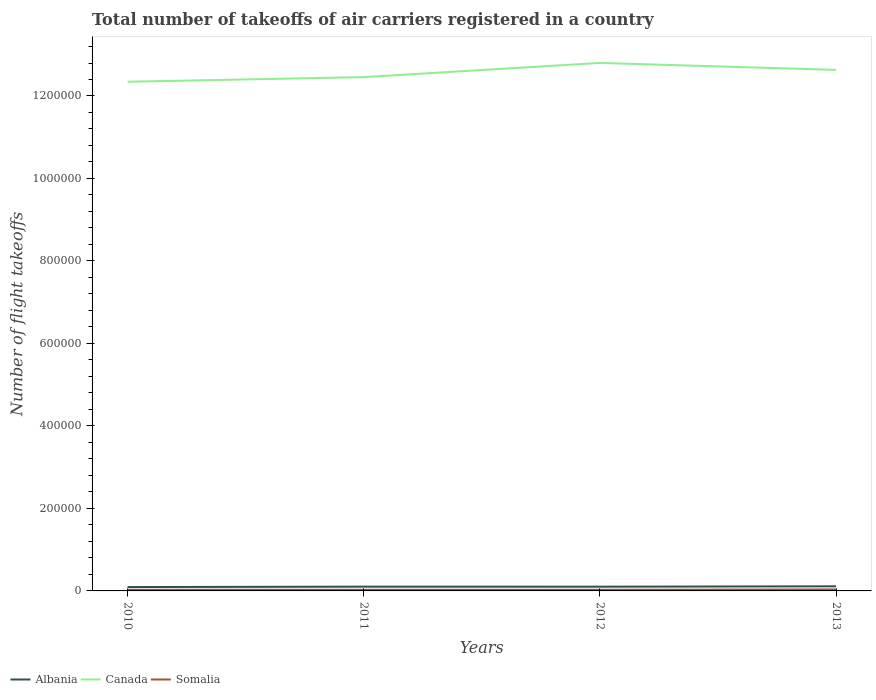Does the line corresponding to Canada intersect with the line corresponding to Somalia?
Your response must be concise. No. Is the number of lines equal to the number of legend labels?
Provide a succinct answer. Yes. Across all years, what is the maximum total number of flight takeoffs in Somalia?
Keep it short and to the point. 2716.91. In which year was the total number of flight takeoffs in Albania maximum?
Ensure brevity in your answer.  2010. What is the total total number of flight takeoffs in Canada in the graph?
Your response must be concise. -4.57e+04. What is the difference between the highest and the second highest total number of flight takeoffs in Canada?
Make the answer very short. 4.57e+04. How many years are there in the graph?
Offer a terse response. 4. What is the difference between two consecutive major ticks on the Y-axis?
Ensure brevity in your answer.  2.00e+05. Are the values on the major ticks of Y-axis written in scientific E-notation?
Offer a terse response. No. Does the graph contain any zero values?
Provide a succinct answer. No. Does the graph contain grids?
Offer a very short reply. No. How many legend labels are there?
Give a very brief answer. 3. How are the legend labels stacked?
Provide a succinct answer. Horizontal. What is the title of the graph?
Give a very brief answer. Total number of takeoffs of air carriers registered in a country. Does "Uzbekistan" appear as one of the legend labels in the graph?
Give a very brief answer. No. What is the label or title of the X-axis?
Ensure brevity in your answer.  Years. What is the label or title of the Y-axis?
Provide a short and direct response. Number of flight takeoffs. What is the Number of flight takeoffs of Albania in 2010?
Offer a very short reply. 9412. What is the Number of flight takeoffs in Canada in 2010?
Give a very brief answer. 1.23e+06. What is the Number of flight takeoffs of Somalia in 2010?
Offer a terse response. 2716.91. What is the Number of flight takeoffs in Albania in 2011?
Keep it short and to the point. 1.04e+04. What is the Number of flight takeoffs of Canada in 2011?
Offer a terse response. 1.25e+06. What is the Number of flight takeoffs of Somalia in 2011?
Offer a terse response. 2815. What is the Number of flight takeoffs of Albania in 2012?
Offer a terse response. 1.03e+04. What is the Number of flight takeoffs in Canada in 2012?
Provide a succinct answer. 1.28e+06. What is the Number of flight takeoffs in Somalia in 2012?
Keep it short and to the point. 2791. What is the Number of flight takeoffs of Albania in 2013?
Make the answer very short. 1.12e+04. What is the Number of flight takeoffs of Canada in 2013?
Make the answer very short. 1.26e+06. What is the Number of flight takeoffs in Somalia in 2013?
Offer a terse response. 3538. Across all years, what is the maximum Number of flight takeoffs of Albania?
Provide a succinct answer. 1.12e+04. Across all years, what is the maximum Number of flight takeoffs in Canada?
Make the answer very short. 1.28e+06. Across all years, what is the maximum Number of flight takeoffs in Somalia?
Ensure brevity in your answer.  3538. Across all years, what is the minimum Number of flight takeoffs in Albania?
Offer a terse response. 9412. Across all years, what is the minimum Number of flight takeoffs of Canada?
Your answer should be compact. 1.23e+06. Across all years, what is the minimum Number of flight takeoffs in Somalia?
Your answer should be compact. 2716.91. What is the total Number of flight takeoffs in Albania in the graph?
Ensure brevity in your answer.  4.13e+04. What is the total Number of flight takeoffs in Canada in the graph?
Offer a terse response. 5.02e+06. What is the total Number of flight takeoffs of Somalia in the graph?
Your answer should be very brief. 1.19e+04. What is the difference between the Number of flight takeoffs of Albania in 2010 and that in 2011?
Your answer should be compact. -961.21. What is the difference between the Number of flight takeoffs in Canada in 2010 and that in 2011?
Provide a short and direct response. -1.12e+04. What is the difference between the Number of flight takeoffs in Somalia in 2010 and that in 2011?
Offer a terse response. -98.09. What is the difference between the Number of flight takeoffs in Albania in 2010 and that in 2012?
Provide a succinct answer. -897.18. What is the difference between the Number of flight takeoffs in Canada in 2010 and that in 2012?
Your answer should be compact. -4.57e+04. What is the difference between the Number of flight takeoffs of Somalia in 2010 and that in 2012?
Ensure brevity in your answer.  -74.09. What is the difference between the Number of flight takeoffs of Albania in 2010 and that in 2013?
Your answer should be very brief. -1777.79. What is the difference between the Number of flight takeoffs in Canada in 2010 and that in 2013?
Your answer should be compact. -2.88e+04. What is the difference between the Number of flight takeoffs of Somalia in 2010 and that in 2013?
Offer a terse response. -821.09. What is the difference between the Number of flight takeoffs in Albania in 2011 and that in 2012?
Provide a short and direct response. 64.03. What is the difference between the Number of flight takeoffs in Canada in 2011 and that in 2012?
Provide a succinct answer. -3.45e+04. What is the difference between the Number of flight takeoffs in Albania in 2011 and that in 2013?
Ensure brevity in your answer.  -816.57. What is the difference between the Number of flight takeoffs in Canada in 2011 and that in 2013?
Your answer should be very brief. -1.76e+04. What is the difference between the Number of flight takeoffs of Somalia in 2011 and that in 2013?
Provide a succinct answer. -723. What is the difference between the Number of flight takeoffs in Albania in 2012 and that in 2013?
Offer a very short reply. -880.61. What is the difference between the Number of flight takeoffs in Canada in 2012 and that in 2013?
Make the answer very short. 1.69e+04. What is the difference between the Number of flight takeoffs of Somalia in 2012 and that in 2013?
Provide a short and direct response. -747. What is the difference between the Number of flight takeoffs in Albania in 2010 and the Number of flight takeoffs in Canada in 2011?
Your answer should be compact. -1.24e+06. What is the difference between the Number of flight takeoffs in Albania in 2010 and the Number of flight takeoffs in Somalia in 2011?
Make the answer very short. 6597. What is the difference between the Number of flight takeoffs in Canada in 2010 and the Number of flight takeoffs in Somalia in 2011?
Ensure brevity in your answer.  1.23e+06. What is the difference between the Number of flight takeoffs of Albania in 2010 and the Number of flight takeoffs of Canada in 2012?
Provide a succinct answer. -1.27e+06. What is the difference between the Number of flight takeoffs in Albania in 2010 and the Number of flight takeoffs in Somalia in 2012?
Ensure brevity in your answer.  6621. What is the difference between the Number of flight takeoffs in Canada in 2010 and the Number of flight takeoffs in Somalia in 2012?
Provide a short and direct response. 1.23e+06. What is the difference between the Number of flight takeoffs in Albania in 2010 and the Number of flight takeoffs in Canada in 2013?
Offer a terse response. -1.25e+06. What is the difference between the Number of flight takeoffs of Albania in 2010 and the Number of flight takeoffs of Somalia in 2013?
Offer a terse response. 5874. What is the difference between the Number of flight takeoffs in Canada in 2010 and the Number of flight takeoffs in Somalia in 2013?
Keep it short and to the point. 1.23e+06. What is the difference between the Number of flight takeoffs of Albania in 2011 and the Number of flight takeoffs of Canada in 2012?
Make the answer very short. -1.27e+06. What is the difference between the Number of flight takeoffs of Albania in 2011 and the Number of flight takeoffs of Somalia in 2012?
Your response must be concise. 7582.21. What is the difference between the Number of flight takeoffs of Canada in 2011 and the Number of flight takeoffs of Somalia in 2012?
Keep it short and to the point. 1.24e+06. What is the difference between the Number of flight takeoffs of Albania in 2011 and the Number of flight takeoffs of Canada in 2013?
Offer a terse response. -1.25e+06. What is the difference between the Number of flight takeoffs of Albania in 2011 and the Number of flight takeoffs of Somalia in 2013?
Keep it short and to the point. 6835.21. What is the difference between the Number of flight takeoffs of Canada in 2011 and the Number of flight takeoffs of Somalia in 2013?
Provide a succinct answer. 1.24e+06. What is the difference between the Number of flight takeoffs in Albania in 2012 and the Number of flight takeoffs in Canada in 2013?
Give a very brief answer. -1.25e+06. What is the difference between the Number of flight takeoffs in Albania in 2012 and the Number of flight takeoffs in Somalia in 2013?
Offer a terse response. 6771.18. What is the difference between the Number of flight takeoffs of Canada in 2012 and the Number of flight takeoffs of Somalia in 2013?
Make the answer very short. 1.28e+06. What is the average Number of flight takeoffs of Albania per year?
Give a very brief answer. 1.03e+04. What is the average Number of flight takeoffs of Canada per year?
Offer a very short reply. 1.26e+06. What is the average Number of flight takeoffs of Somalia per year?
Offer a terse response. 2965.23. In the year 2010, what is the difference between the Number of flight takeoffs of Albania and Number of flight takeoffs of Canada?
Ensure brevity in your answer.  -1.23e+06. In the year 2010, what is the difference between the Number of flight takeoffs of Albania and Number of flight takeoffs of Somalia?
Your answer should be very brief. 6695.09. In the year 2010, what is the difference between the Number of flight takeoffs in Canada and Number of flight takeoffs in Somalia?
Provide a succinct answer. 1.23e+06. In the year 2011, what is the difference between the Number of flight takeoffs of Albania and Number of flight takeoffs of Canada?
Offer a terse response. -1.24e+06. In the year 2011, what is the difference between the Number of flight takeoffs in Albania and Number of flight takeoffs in Somalia?
Your answer should be compact. 7558.21. In the year 2011, what is the difference between the Number of flight takeoffs of Canada and Number of flight takeoffs of Somalia?
Ensure brevity in your answer.  1.24e+06. In the year 2012, what is the difference between the Number of flight takeoffs in Albania and Number of flight takeoffs in Canada?
Offer a terse response. -1.27e+06. In the year 2012, what is the difference between the Number of flight takeoffs of Albania and Number of flight takeoffs of Somalia?
Your answer should be very brief. 7518.18. In the year 2012, what is the difference between the Number of flight takeoffs in Canada and Number of flight takeoffs in Somalia?
Keep it short and to the point. 1.28e+06. In the year 2013, what is the difference between the Number of flight takeoffs of Albania and Number of flight takeoffs of Canada?
Make the answer very short. -1.25e+06. In the year 2013, what is the difference between the Number of flight takeoffs of Albania and Number of flight takeoffs of Somalia?
Ensure brevity in your answer.  7651.79. In the year 2013, what is the difference between the Number of flight takeoffs in Canada and Number of flight takeoffs in Somalia?
Make the answer very short. 1.26e+06. What is the ratio of the Number of flight takeoffs in Albania in 2010 to that in 2011?
Your response must be concise. 0.91. What is the ratio of the Number of flight takeoffs of Canada in 2010 to that in 2011?
Give a very brief answer. 0.99. What is the ratio of the Number of flight takeoffs in Somalia in 2010 to that in 2011?
Make the answer very short. 0.97. What is the ratio of the Number of flight takeoffs in Canada in 2010 to that in 2012?
Provide a short and direct response. 0.96. What is the ratio of the Number of flight takeoffs of Somalia in 2010 to that in 2012?
Provide a succinct answer. 0.97. What is the ratio of the Number of flight takeoffs in Albania in 2010 to that in 2013?
Keep it short and to the point. 0.84. What is the ratio of the Number of flight takeoffs in Canada in 2010 to that in 2013?
Your answer should be very brief. 0.98. What is the ratio of the Number of flight takeoffs in Somalia in 2010 to that in 2013?
Your response must be concise. 0.77. What is the ratio of the Number of flight takeoffs in Canada in 2011 to that in 2012?
Provide a short and direct response. 0.97. What is the ratio of the Number of flight takeoffs in Somalia in 2011 to that in 2012?
Offer a very short reply. 1.01. What is the ratio of the Number of flight takeoffs in Albania in 2011 to that in 2013?
Offer a very short reply. 0.93. What is the ratio of the Number of flight takeoffs of Canada in 2011 to that in 2013?
Your response must be concise. 0.99. What is the ratio of the Number of flight takeoffs of Somalia in 2011 to that in 2013?
Keep it short and to the point. 0.8. What is the ratio of the Number of flight takeoffs of Albania in 2012 to that in 2013?
Keep it short and to the point. 0.92. What is the ratio of the Number of flight takeoffs in Canada in 2012 to that in 2013?
Offer a terse response. 1.01. What is the ratio of the Number of flight takeoffs of Somalia in 2012 to that in 2013?
Offer a terse response. 0.79. What is the difference between the highest and the second highest Number of flight takeoffs of Albania?
Provide a succinct answer. 816.57. What is the difference between the highest and the second highest Number of flight takeoffs in Canada?
Provide a short and direct response. 1.69e+04. What is the difference between the highest and the second highest Number of flight takeoffs of Somalia?
Offer a very short reply. 723. What is the difference between the highest and the lowest Number of flight takeoffs in Albania?
Offer a very short reply. 1777.79. What is the difference between the highest and the lowest Number of flight takeoffs of Canada?
Provide a succinct answer. 4.57e+04. What is the difference between the highest and the lowest Number of flight takeoffs of Somalia?
Give a very brief answer. 821.09. 